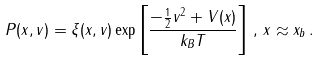Convert formula to latex. <formula><loc_0><loc_0><loc_500><loc_500>P ( x , v ) = \xi ( x , v ) \exp \left [ \frac { - \frac { 1 } { 2 } v ^ { 2 } + V ( x ) } { k _ { B } T } \right ] \, , \, x \approx x _ { b } \, .</formula> 